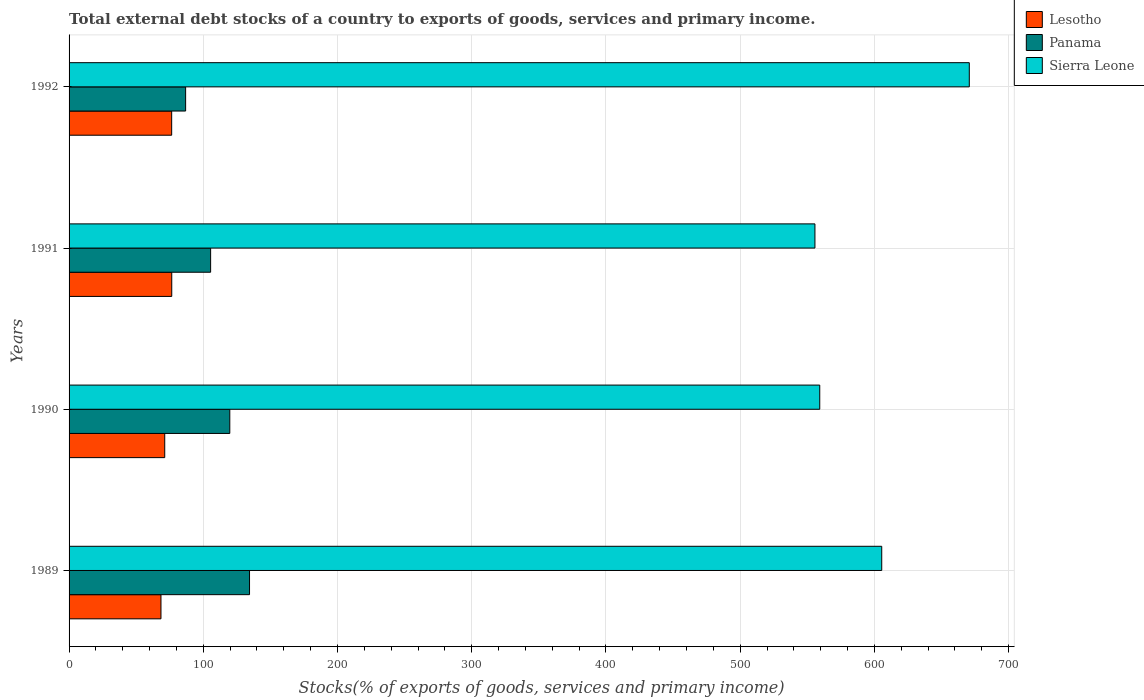How many different coloured bars are there?
Give a very brief answer. 3. How many groups of bars are there?
Keep it short and to the point. 4. How many bars are there on the 3rd tick from the top?
Make the answer very short. 3. How many bars are there on the 3rd tick from the bottom?
Keep it short and to the point. 3. What is the label of the 2nd group of bars from the top?
Offer a terse response. 1991. In how many cases, is the number of bars for a given year not equal to the number of legend labels?
Offer a terse response. 0. What is the total debt stocks in Sierra Leone in 1992?
Make the answer very short. 670.67. Across all years, what is the maximum total debt stocks in Panama?
Provide a short and direct response. 134.44. Across all years, what is the minimum total debt stocks in Lesotho?
Make the answer very short. 68.47. In which year was the total debt stocks in Sierra Leone minimum?
Give a very brief answer. 1991. What is the total total debt stocks in Lesotho in the graph?
Make the answer very short. 292.68. What is the difference between the total debt stocks in Sierra Leone in 1989 and that in 1992?
Ensure brevity in your answer.  -65.23. What is the difference between the total debt stocks in Panama in 1991 and the total debt stocks in Sierra Leone in 1989?
Provide a succinct answer. -499.98. What is the average total debt stocks in Sierra Leone per year?
Make the answer very short. 597.76. In the year 1992, what is the difference between the total debt stocks in Lesotho and total debt stocks in Panama?
Give a very brief answer. -10.39. What is the ratio of the total debt stocks in Panama in 1989 to that in 1990?
Give a very brief answer. 1.12. Is the total debt stocks in Sierra Leone in 1990 less than that in 1991?
Your response must be concise. No. Is the difference between the total debt stocks in Lesotho in 1989 and 1991 greater than the difference between the total debt stocks in Panama in 1989 and 1991?
Provide a short and direct response. No. What is the difference between the highest and the second highest total debt stocks in Lesotho?
Keep it short and to the point. 0.06. What is the difference between the highest and the lowest total debt stocks in Panama?
Your response must be concise. 47.61. In how many years, is the total debt stocks in Panama greater than the average total debt stocks in Panama taken over all years?
Offer a terse response. 2. What does the 1st bar from the top in 1989 represents?
Ensure brevity in your answer.  Sierra Leone. What does the 3rd bar from the bottom in 1991 represents?
Your response must be concise. Sierra Leone. Are the values on the major ticks of X-axis written in scientific E-notation?
Keep it short and to the point. No. Does the graph contain any zero values?
Offer a very short reply. No. How many legend labels are there?
Give a very brief answer. 3. What is the title of the graph?
Offer a terse response. Total external debt stocks of a country to exports of goods, services and primary income. What is the label or title of the X-axis?
Make the answer very short. Stocks(% of exports of goods, services and primary income). What is the Stocks(% of exports of goods, services and primary income) in Lesotho in 1989?
Your response must be concise. 68.47. What is the Stocks(% of exports of goods, services and primary income) in Panama in 1989?
Provide a succinct answer. 134.44. What is the Stocks(% of exports of goods, services and primary income) in Sierra Leone in 1989?
Ensure brevity in your answer.  605.44. What is the Stocks(% of exports of goods, services and primary income) of Lesotho in 1990?
Ensure brevity in your answer.  71.27. What is the Stocks(% of exports of goods, services and primary income) in Panama in 1990?
Offer a terse response. 119.74. What is the Stocks(% of exports of goods, services and primary income) in Sierra Leone in 1990?
Ensure brevity in your answer.  559.26. What is the Stocks(% of exports of goods, services and primary income) in Lesotho in 1991?
Provide a short and direct response. 76.5. What is the Stocks(% of exports of goods, services and primary income) in Panama in 1991?
Provide a short and direct response. 105.46. What is the Stocks(% of exports of goods, services and primary income) in Sierra Leone in 1991?
Your response must be concise. 555.67. What is the Stocks(% of exports of goods, services and primary income) of Lesotho in 1992?
Keep it short and to the point. 76.44. What is the Stocks(% of exports of goods, services and primary income) of Panama in 1992?
Make the answer very short. 86.83. What is the Stocks(% of exports of goods, services and primary income) of Sierra Leone in 1992?
Your response must be concise. 670.67. Across all years, what is the maximum Stocks(% of exports of goods, services and primary income) of Lesotho?
Offer a very short reply. 76.5. Across all years, what is the maximum Stocks(% of exports of goods, services and primary income) in Panama?
Your answer should be compact. 134.44. Across all years, what is the maximum Stocks(% of exports of goods, services and primary income) in Sierra Leone?
Give a very brief answer. 670.67. Across all years, what is the minimum Stocks(% of exports of goods, services and primary income) in Lesotho?
Your answer should be very brief. 68.47. Across all years, what is the minimum Stocks(% of exports of goods, services and primary income) in Panama?
Provide a short and direct response. 86.83. Across all years, what is the minimum Stocks(% of exports of goods, services and primary income) in Sierra Leone?
Provide a short and direct response. 555.67. What is the total Stocks(% of exports of goods, services and primary income) in Lesotho in the graph?
Offer a terse response. 292.68. What is the total Stocks(% of exports of goods, services and primary income) in Panama in the graph?
Provide a succinct answer. 446.47. What is the total Stocks(% of exports of goods, services and primary income) of Sierra Leone in the graph?
Ensure brevity in your answer.  2391.04. What is the difference between the Stocks(% of exports of goods, services and primary income) in Lesotho in 1989 and that in 1990?
Provide a succinct answer. -2.8. What is the difference between the Stocks(% of exports of goods, services and primary income) in Panama in 1989 and that in 1990?
Offer a very short reply. 14.7. What is the difference between the Stocks(% of exports of goods, services and primary income) of Sierra Leone in 1989 and that in 1990?
Make the answer very short. 46.17. What is the difference between the Stocks(% of exports of goods, services and primary income) of Lesotho in 1989 and that in 1991?
Keep it short and to the point. -8.03. What is the difference between the Stocks(% of exports of goods, services and primary income) of Panama in 1989 and that in 1991?
Offer a very short reply. 28.98. What is the difference between the Stocks(% of exports of goods, services and primary income) of Sierra Leone in 1989 and that in 1991?
Provide a short and direct response. 49.76. What is the difference between the Stocks(% of exports of goods, services and primary income) of Lesotho in 1989 and that in 1992?
Give a very brief answer. -7.97. What is the difference between the Stocks(% of exports of goods, services and primary income) of Panama in 1989 and that in 1992?
Offer a terse response. 47.61. What is the difference between the Stocks(% of exports of goods, services and primary income) of Sierra Leone in 1989 and that in 1992?
Your response must be concise. -65.23. What is the difference between the Stocks(% of exports of goods, services and primary income) in Lesotho in 1990 and that in 1991?
Ensure brevity in your answer.  -5.23. What is the difference between the Stocks(% of exports of goods, services and primary income) of Panama in 1990 and that in 1991?
Give a very brief answer. 14.28. What is the difference between the Stocks(% of exports of goods, services and primary income) in Sierra Leone in 1990 and that in 1991?
Your response must be concise. 3.59. What is the difference between the Stocks(% of exports of goods, services and primary income) of Lesotho in 1990 and that in 1992?
Your answer should be compact. -5.17. What is the difference between the Stocks(% of exports of goods, services and primary income) of Panama in 1990 and that in 1992?
Ensure brevity in your answer.  32.91. What is the difference between the Stocks(% of exports of goods, services and primary income) in Sierra Leone in 1990 and that in 1992?
Provide a short and direct response. -111.41. What is the difference between the Stocks(% of exports of goods, services and primary income) of Lesotho in 1991 and that in 1992?
Keep it short and to the point. 0.06. What is the difference between the Stocks(% of exports of goods, services and primary income) of Panama in 1991 and that in 1992?
Provide a short and direct response. 18.63. What is the difference between the Stocks(% of exports of goods, services and primary income) of Sierra Leone in 1991 and that in 1992?
Your response must be concise. -115. What is the difference between the Stocks(% of exports of goods, services and primary income) of Lesotho in 1989 and the Stocks(% of exports of goods, services and primary income) of Panama in 1990?
Offer a very short reply. -51.27. What is the difference between the Stocks(% of exports of goods, services and primary income) in Lesotho in 1989 and the Stocks(% of exports of goods, services and primary income) in Sierra Leone in 1990?
Offer a very short reply. -490.8. What is the difference between the Stocks(% of exports of goods, services and primary income) of Panama in 1989 and the Stocks(% of exports of goods, services and primary income) of Sierra Leone in 1990?
Your response must be concise. -424.82. What is the difference between the Stocks(% of exports of goods, services and primary income) in Lesotho in 1989 and the Stocks(% of exports of goods, services and primary income) in Panama in 1991?
Your answer should be very brief. -36.99. What is the difference between the Stocks(% of exports of goods, services and primary income) of Lesotho in 1989 and the Stocks(% of exports of goods, services and primary income) of Sierra Leone in 1991?
Ensure brevity in your answer.  -487.2. What is the difference between the Stocks(% of exports of goods, services and primary income) of Panama in 1989 and the Stocks(% of exports of goods, services and primary income) of Sierra Leone in 1991?
Provide a succinct answer. -421.23. What is the difference between the Stocks(% of exports of goods, services and primary income) of Lesotho in 1989 and the Stocks(% of exports of goods, services and primary income) of Panama in 1992?
Ensure brevity in your answer.  -18.36. What is the difference between the Stocks(% of exports of goods, services and primary income) of Lesotho in 1989 and the Stocks(% of exports of goods, services and primary income) of Sierra Leone in 1992?
Give a very brief answer. -602.2. What is the difference between the Stocks(% of exports of goods, services and primary income) in Panama in 1989 and the Stocks(% of exports of goods, services and primary income) in Sierra Leone in 1992?
Give a very brief answer. -536.23. What is the difference between the Stocks(% of exports of goods, services and primary income) of Lesotho in 1990 and the Stocks(% of exports of goods, services and primary income) of Panama in 1991?
Provide a succinct answer. -34.18. What is the difference between the Stocks(% of exports of goods, services and primary income) in Lesotho in 1990 and the Stocks(% of exports of goods, services and primary income) in Sierra Leone in 1991?
Your answer should be very brief. -484.4. What is the difference between the Stocks(% of exports of goods, services and primary income) of Panama in 1990 and the Stocks(% of exports of goods, services and primary income) of Sierra Leone in 1991?
Ensure brevity in your answer.  -435.93. What is the difference between the Stocks(% of exports of goods, services and primary income) of Lesotho in 1990 and the Stocks(% of exports of goods, services and primary income) of Panama in 1992?
Provide a succinct answer. -15.56. What is the difference between the Stocks(% of exports of goods, services and primary income) of Lesotho in 1990 and the Stocks(% of exports of goods, services and primary income) of Sierra Leone in 1992?
Ensure brevity in your answer.  -599.4. What is the difference between the Stocks(% of exports of goods, services and primary income) in Panama in 1990 and the Stocks(% of exports of goods, services and primary income) in Sierra Leone in 1992?
Your response must be concise. -550.93. What is the difference between the Stocks(% of exports of goods, services and primary income) in Lesotho in 1991 and the Stocks(% of exports of goods, services and primary income) in Panama in 1992?
Your answer should be compact. -10.33. What is the difference between the Stocks(% of exports of goods, services and primary income) in Lesotho in 1991 and the Stocks(% of exports of goods, services and primary income) in Sierra Leone in 1992?
Your answer should be very brief. -594.17. What is the difference between the Stocks(% of exports of goods, services and primary income) of Panama in 1991 and the Stocks(% of exports of goods, services and primary income) of Sierra Leone in 1992?
Ensure brevity in your answer.  -565.21. What is the average Stocks(% of exports of goods, services and primary income) in Lesotho per year?
Your answer should be very brief. 73.17. What is the average Stocks(% of exports of goods, services and primary income) of Panama per year?
Offer a terse response. 111.62. What is the average Stocks(% of exports of goods, services and primary income) in Sierra Leone per year?
Your response must be concise. 597.76. In the year 1989, what is the difference between the Stocks(% of exports of goods, services and primary income) of Lesotho and Stocks(% of exports of goods, services and primary income) of Panama?
Offer a very short reply. -65.97. In the year 1989, what is the difference between the Stocks(% of exports of goods, services and primary income) of Lesotho and Stocks(% of exports of goods, services and primary income) of Sierra Leone?
Keep it short and to the point. -536.97. In the year 1989, what is the difference between the Stocks(% of exports of goods, services and primary income) of Panama and Stocks(% of exports of goods, services and primary income) of Sierra Leone?
Ensure brevity in your answer.  -471. In the year 1990, what is the difference between the Stocks(% of exports of goods, services and primary income) of Lesotho and Stocks(% of exports of goods, services and primary income) of Panama?
Make the answer very short. -48.47. In the year 1990, what is the difference between the Stocks(% of exports of goods, services and primary income) in Lesotho and Stocks(% of exports of goods, services and primary income) in Sierra Leone?
Offer a very short reply. -487.99. In the year 1990, what is the difference between the Stocks(% of exports of goods, services and primary income) of Panama and Stocks(% of exports of goods, services and primary income) of Sierra Leone?
Give a very brief answer. -439.52. In the year 1991, what is the difference between the Stocks(% of exports of goods, services and primary income) of Lesotho and Stocks(% of exports of goods, services and primary income) of Panama?
Your response must be concise. -28.96. In the year 1991, what is the difference between the Stocks(% of exports of goods, services and primary income) in Lesotho and Stocks(% of exports of goods, services and primary income) in Sierra Leone?
Provide a short and direct response. -479.17. In the year 1991, what is the difference between the Stocks(% of exports of goods, services and primary income) in Panama and Stocks(% of exports of goods, services and primary income) in Sierra Leone?
Give a very brief answer. -450.22. In the year 1992, what is the difference between the Stocks(% of exports of goods, services and primary income) in Lesotho and Stocks(% of exports of goods, services and primary income) in Panama?
Provide a short and direct response. -10.39. In the year 1992, what is the difference between the Stocks(% of exports of goods, services and primary income) in Lesotho and Stocks(% of exports of goods, services and primary income) in Sierra Leone?
Offer a terse response. -594.23. In the year 1992, what is the difference between the Stocks(% of exports of goods, services and primary income) of Panama and Stocks(% of exports of goods, services and primary income) of Sierra Leone?
Keep it short and to the point. -583.84. What is the ratio of the Stocks(% of exports of goods, services and primary income) of Lesotho in 1989 to that in 1990?
Provide a short and direct response. 0.96. What is the ratio of the Stocks(% of exports of goods, services and primary income) of Panama in 1989 to that in 1990?
Give a very brief answer. 1.12. What is the ratio of the Stocks(% of exports of goods, services and primary income) of Sierra Leone in 1989 to that in 1990?
Give a very brief answer. 1.08. What is the ratio of the Stocks(% of exports of goods, services and primary income) in Lesotho in 1989 to that in 1991?
Keep it short and to the point. 0.9. What is the ratio of the Stocks(% of exports of goods, services and primary income) in Panama in 1989 to that in 1991?
Your answer should be very brief. 1.27. What is the ratio of the Stocks(% of exports of goods, services and primary income) of Sierra Leone in 1989 to that in 1991?
Provide a short and direct response. 1.09. What is the ratio of the Stocks(% of exports of goods, services and primary income) of Lesotho in 1989 to that in 1992?
Your answer should be compact. 0.9. What is the ratio of the Stocks(% of exports of goods, services and primary income) in Panama in 1989 to that in 1992?
Make the answer very short. 1.55. What is the ratio of the Stocks(% of exports of goods, services and primary income) of Sierra Leone in 1989 to that in 1992?
Provide a succinct answer. 0.9. What is the ratio of the Stocks(% of exports of goods, services and primary income) in Lesotho in 1990 to that in 1991?
Offer a very short reply. 0.93. What is the ratio of the Stocks(% of exports of goods, services and primary income) in Panama in 1990 to that in 1991?
Ensure brevity in your answer.  1.14. What is the ratio of the Stocks(% of exports of goods, services and primary income) of Lesotho in 1990 to that in 1992?
Offer a very short reply. 0.93. What is the ratio of the Stocks(% of exports of goods, services and primary income) in Panama in 1990 to that in 1992?
Ensure brevity in your answer.  1.38. What is the ratio of the Stocks(% of exports of goods, services and primary income) of Sierra Leone in 1990 to that in 1992?
Your answer should be compact. 0.83. What is the ratio of the Stocks(% of exports of goods, services and primary income) of Lesotho in 1991 to that in 1992?
Your response must be concise. 1. What is the ratio of the Stocks(% of exports of goods, services and primary income) of Panama in 1991 to that in 1992?
Your response must be concise. 1.21. What is the ratio of the Stocks(% of exports of goods, services and primary income) in Sierra Leone in 1991 to that in 1992?
Provide a short and direct response. 0.83. What is the difference between the highest and the second highest Stocks(% of exports of goods, services and primary income) of Lesotho?
Provide a succinct answer. 0.06. What is the difference between the highest and the second highest Stocks(% of exports of goods, services and primary income) in Panama?
Your answer should be very brief. 14.7. What is the difference between the highest and the second highest Stocks(% of exports of goods, services and primary income) of Sierra Leone?
Give a very brief answer. 65.23. What is the difference between the highest and the lowest Stocks(% of exports of goods, services and primary income) in Lesotho?
Your answer should be very brief. 8.03. What is the difference between the highest and the lowest Stocks(% of exports of goods, services and primary income) of Panama?
Your response must be concise. 47.61. What is the difference between the highest and the lowest Stocks(% of exports of goods, services and primary income) in Sierra Leone?
Your answer should be very brief. 115. 